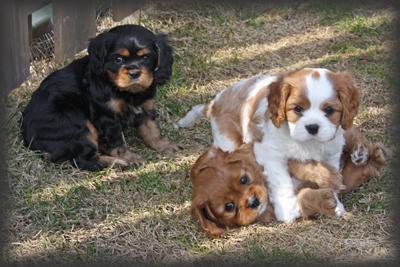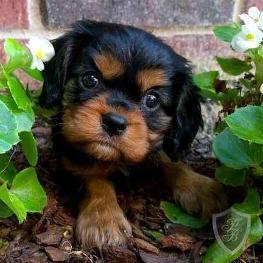The first image is the image on the left, the second image is the image on the right. For the images displayed, is the sentence "A horizontal row of four spaniels in similar poses includes dogs of different colors." factually correct? Answer yes or no. No. The first image is the image on the left, the second image is the image on the right. Analyze the images presented: Is the assertion "The right image contains exactly four dogs seated in a horizontal row." valid? Answer yes or no. No. 